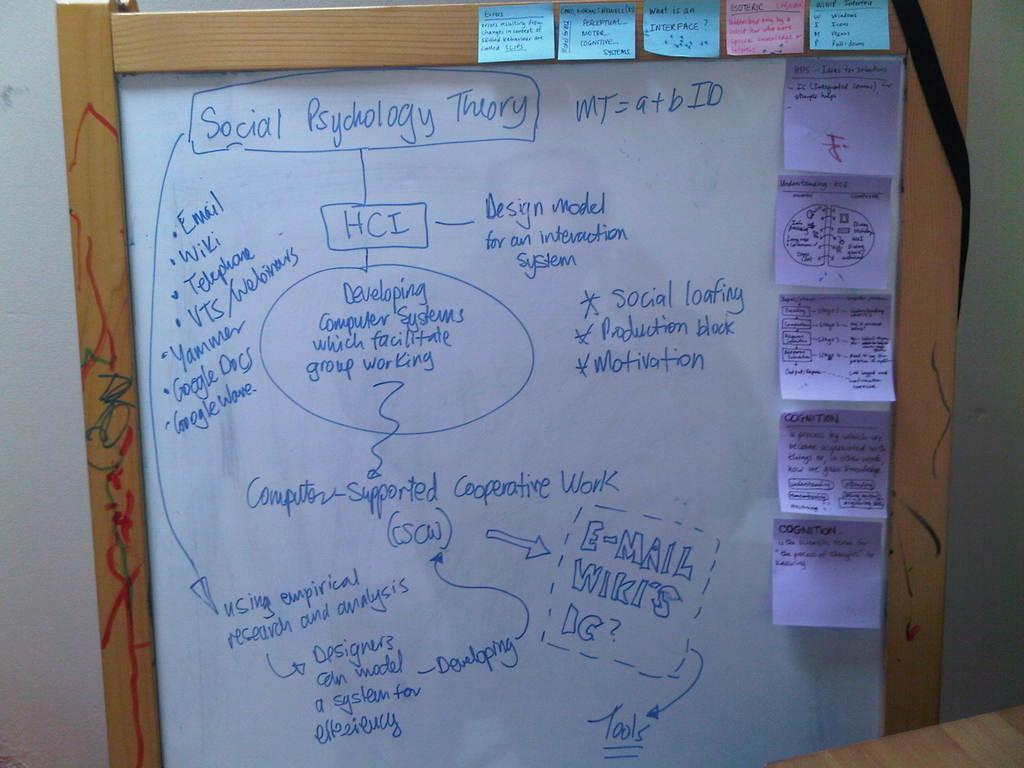<image>
Write a terse but informative summary of the picture. Someone has diagrammed some ideas about social psychology theory 